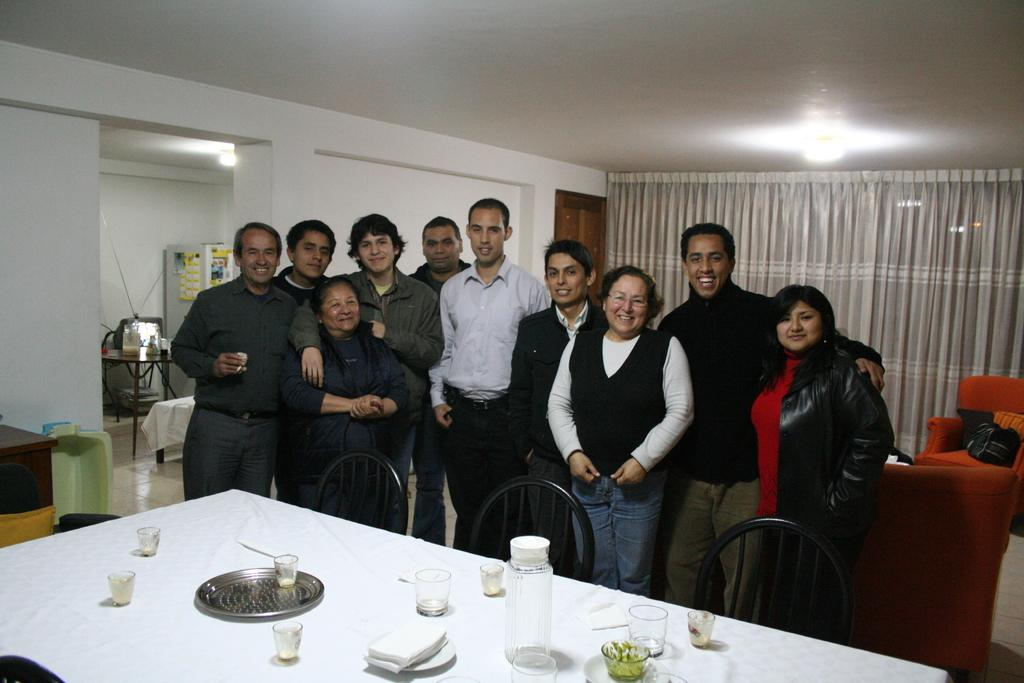What are the people in the image doing? The group of people are posing for a photo. What is in front of the group of people? There is a dining table in front of the group. How many cans are visible on the dining table in the image? There is no mention of cans in the image, so we cannot determine the number of cans present. 